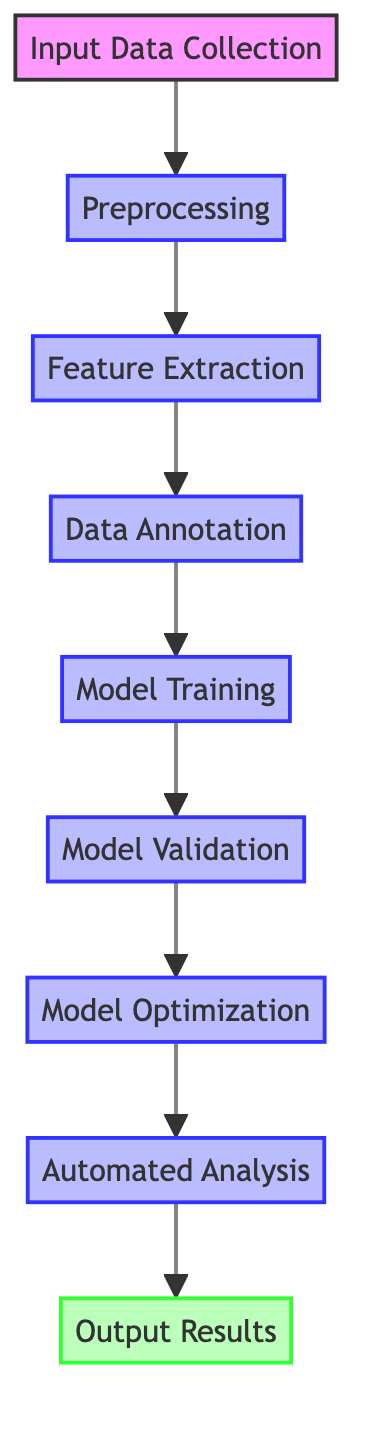What is the first step in the workflow? The flowchart indicates that "Input Data Collection" is the first node, which is the initial step in the workflow process.
Answer: Input Data Collection How many nodes are there in total? By counting each node listed in the flowchart, there are a total of nine nodes that represent different stages in the workflow.
Answer: Nine What follows 'Model Training'? The diagram shows that after 'Model Training', the next step is 'Model Validation', illustrating the flow of the process.
Answer: Model Validation Which step requires human experts? The flowchart specifies 'Data Annotation' as the step where human experts label features, demonstrating the need for expertise in this phase.
Answer: Data Annotation What type of analysis is performed in the last step? The final node 'Output Results' indicates that the analysis involves generating and presenting results, focusing on the nature of output at the end of the process.
Answer: Automated Analysis What must be done before 'Automated Analysis'? Looking at the flowchart, it is clear that 'Model Optimization' must be completed before 'Automated Analysis' can take place, highlighting the necessary preceding step.
Answer: Model Optimization How is 'Model Validation' evaluated? The flowchart states that 'Model Validation' is evaluated using metrics like accuracy, F1-score, and confusion matrix, showcasing the performance measures involved.
Answer: Evaluation metrics What tool is suggested for Feature Extraction? According to the flowchart, 'LibROSA' or 'Music21' are mentioned as tools for Feature Extraction, indicating available resources for this task.
Answer: LibROSA or Music21 What happens after feature extraction? The diagram indicates that after 'Feature Extraction', the process moves to 'Data Annotation', the next step in the workflow.
Answer: Data Annotation 